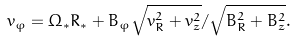Convert formula to latex. <formula><loc_0><loc_0><loc_500><loc_500>v _ { \varphi } = \Omega _ { * } R _ { * } + B _ { \varphi } \sqrt { v _ { R } ^ { 2 } + v _ { z } ^ { 2 } } / \sqrt { B _ { R } ^ { 2 } + B _ { z } ^ { 2 } } .</formula> 